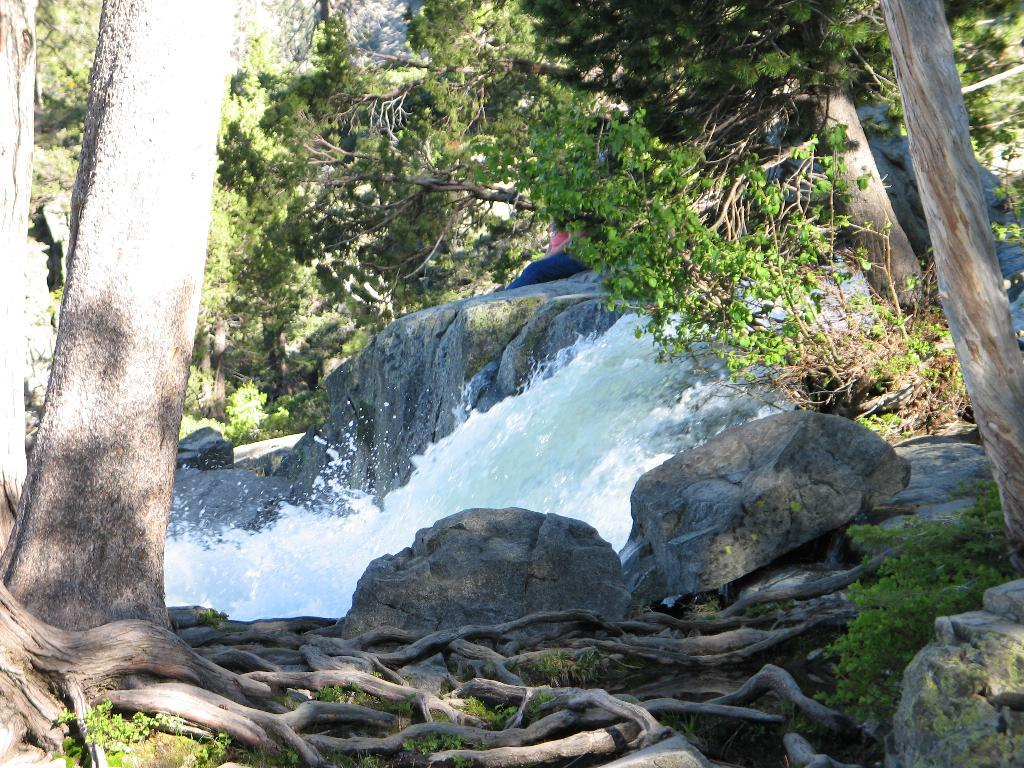What type of vegetation can be seen in the image? There are trees in the image. What type of natural material is present in the image? There are stones in the image. What can be seen in the background of the image? There is flowing water in the background of the image. What type of jam is being spread on the base in the image? There is no jam or base present in the image; it features trees, stones, and flowing water. 